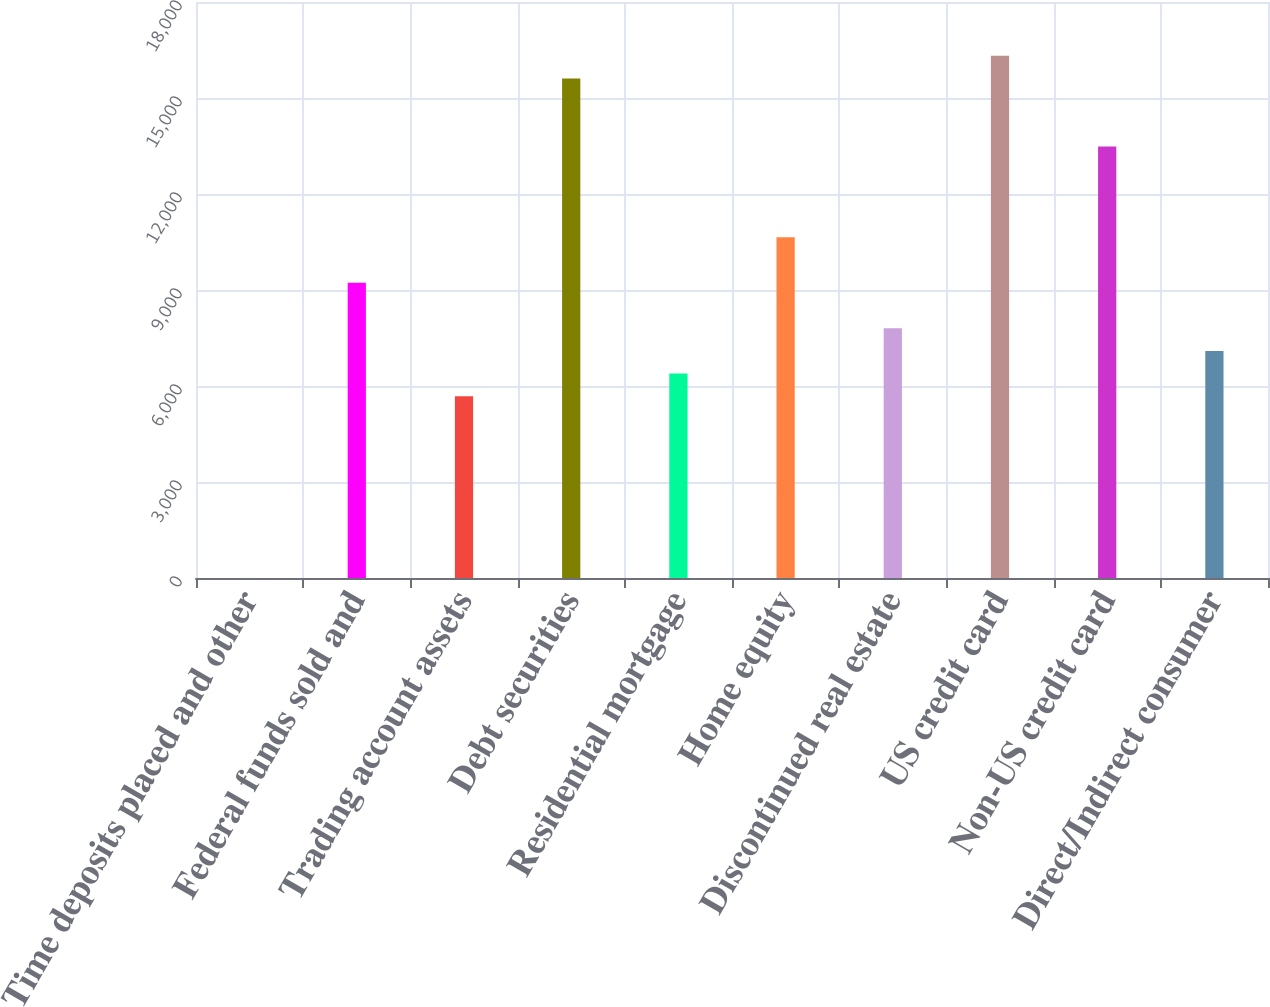<chart> <loc_0><loc_0><loc_500><loc_500><bar_chart><fcel>Time deposits placed and other<fcel>Federal funds sold and<fcel>Trading account assets<fcel>Debt securities<fcel>Residential mortgage<fcel>Home equity<fcel>Discontinued real estate<fcel>US credit card<fcel>Non-US credit card<fcel>Direct/Indirect consumer<nl><fcel>1<fcel>9225.8<fcel>5677.8<fcel>15612.2<fcel>6387.4<fcel>10645<fcel>7806.6<fcel>16321.8<fcel>13483.4<fcel>7097<nl></chart> 